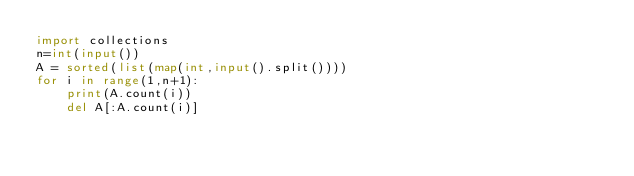Convert code to text. <code><loc_0><loc_0><loc_500><loc_500><_Python_>import collections
n=int(input())
A = sorted(list(map(int,input().split())))
for i in range(1,n+1):
    print(A.count(i))
    del A[:A.count(i)]
    </code> 